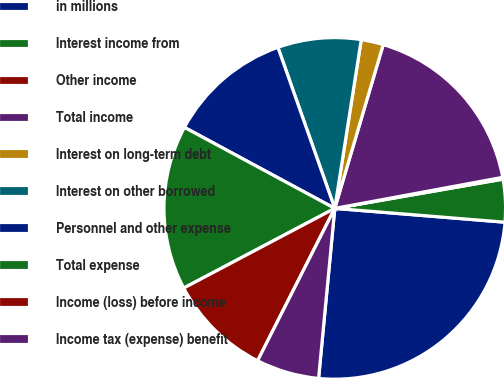<chart> <loc_0><loc_0><loc_500><loc_500><pie_chart><fcel>in millions<fcel>Interest income from<fcel>Other income<fcel>Total income<fcel>Interest on long-term debt<fcel>Interest on other borrowed<fcel>Personnel and other expense<fcel>Total expense<fcel>Income (loss) before income<fcel>Income tax (expense) benefit<nl><fcel>25.22%<fcel>4.03%<fcel>0.17%<fcel>17.51%<fcel>2.1%<fcel>7.88%<fcel>11.73%<fcel>15.59%<fcel>9.81%<fcel>5.95%<nl></chart> 